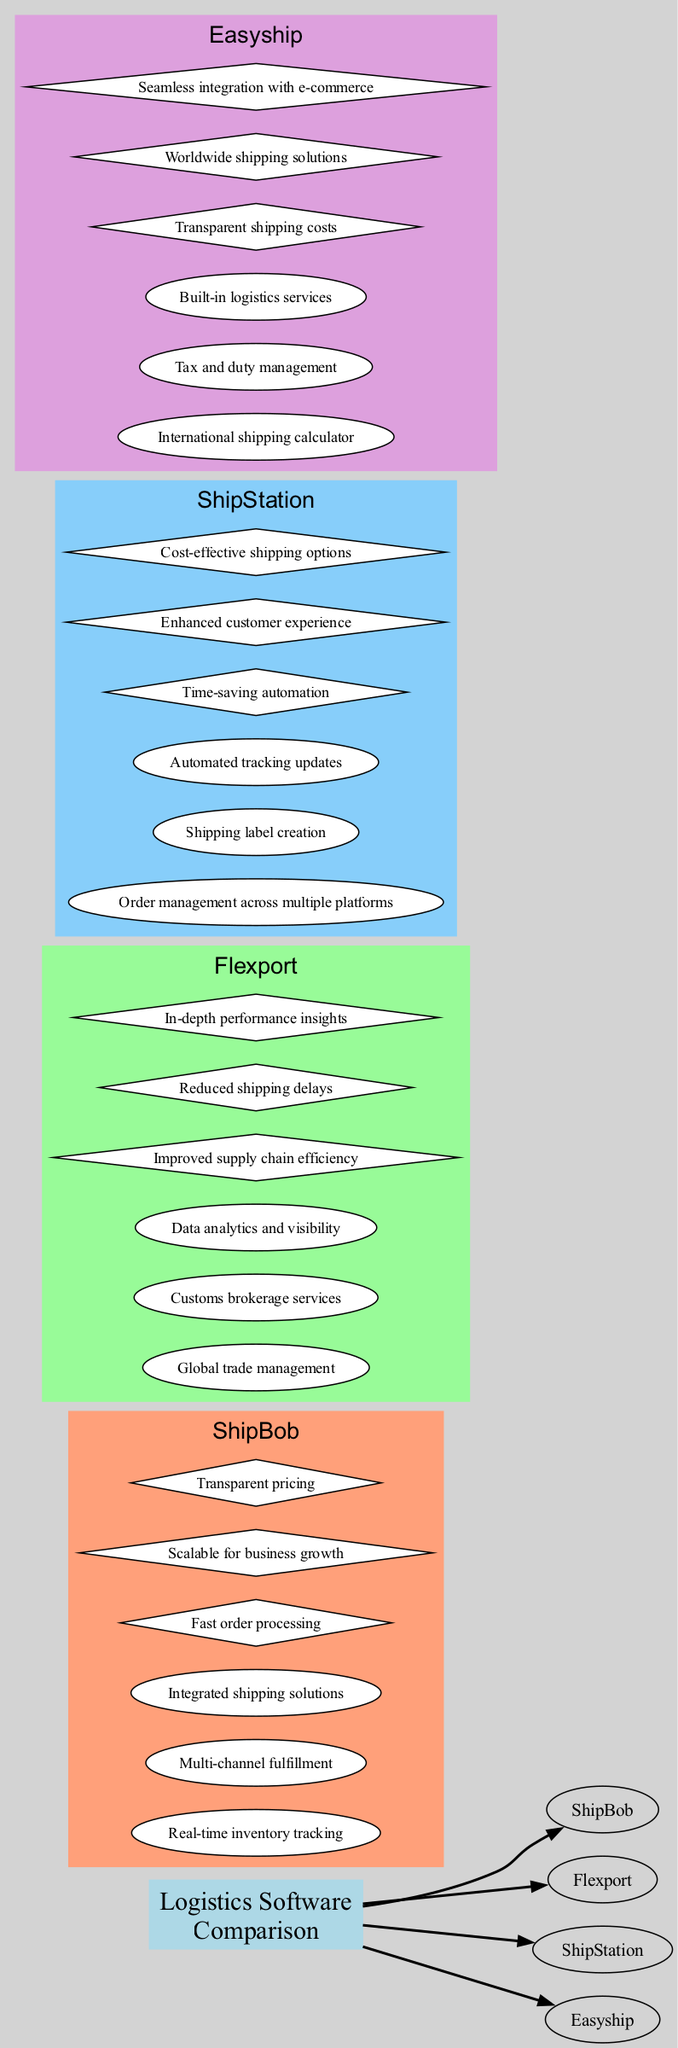What is the first software option listed in the diagram? The first node under "Logistics Software Comparison" represents the software option "ShipBob."
Answer: ShipBob How many features does "Flexport" offer? The diagram indicates that "Flexport" has three features listed under its name.
Answer: 3 Which software has the benefit of "Seamless integration with e-commerce"? By checking the benefit nodes under "Easyship," we can see that "Seamless integration with e-commerce" is listed there.
Answer: Easyship What color represents the "ShipStation" software option? In the diagram, the color associated with "ShipStation" is identified through the subgraph color, which is light blue.
Answer: Light blue Which software option provides "Real-time inventory tracking"? The feature "Real-time inventory tracking" is directly linked to "ShipBob" in the diagram, indicating its unique offering.
Answer: ShipBob What is the total number of benefits listed for "ShipBob"? In the diagram, "ShipBob" is shown to have three benefits listed underneath its node.
Answer: 3 Which software has the largest number of features? Analyzing the features across all software, "ShipStation" has the same number of features as "Flexport," making them the options with the largest number.
Answer: ShipStation and Flexport How does "Easyship" compare to "Flexport" in terms of benefits? "Easyship" has three benefits listed, which is identical to the number of benefits for "Flexport," meaning they are equal in this regard.
Answer: Equal What type of node is used for benefits in the diagram? The diagram distinctly shows that benefits are represented by diamond-shaped nodes, differentiating them from feature nodes.
Answer: Diamond 